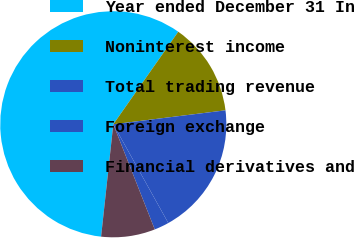Convert chart to OTSL. <chart><loc_0><loc_0><loc_500><loc_500><pie_chart><fcel>Year ended December 31 In<fcel>Noninterest income<fcel>Total trading revenue<fcel>Foreign exchange<fcel>Financial derivatives and<nl><fcel>58.02%<fcel>13.29%<fcel>18.88%<fcel>2.11%<fcel>7.7%<nl></chart> 